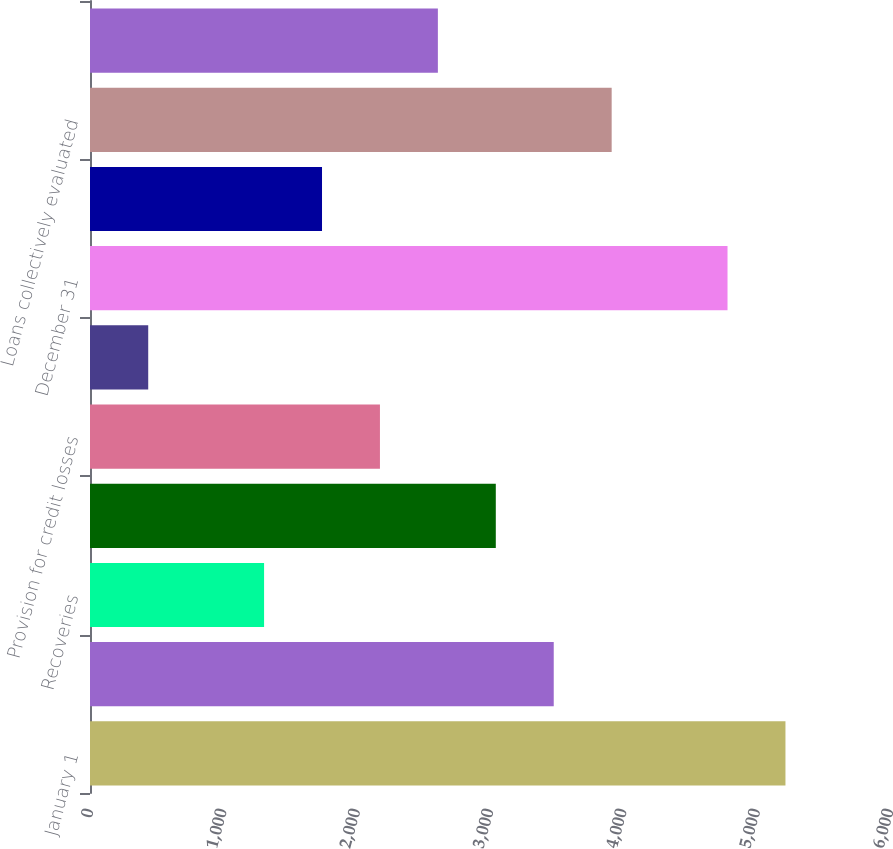Convert chart. <chart><loc_0><loc_0><loc_500><loc_500><bar_chart><fcel>January 1<fcel>Charge-offs<fcel>Recoveries<fcel>Net charge-offs<fcel>Provision for credit losses<fcel>Net change in allowance for<fcel>December 31<fcel>TDRs individually evaluated<fcel>Loans collectively evaluated<fcel>Purchased impaired loans<nl><fcel>5215.93<fcel>3478.01<fcel>1305.61<fcel>3043.53<fcel>2174.57<fcel>436.65<fcel>4781.45<fcel>1740.09<fcel>3912.49<fcel>2609.05<nl></chart> 